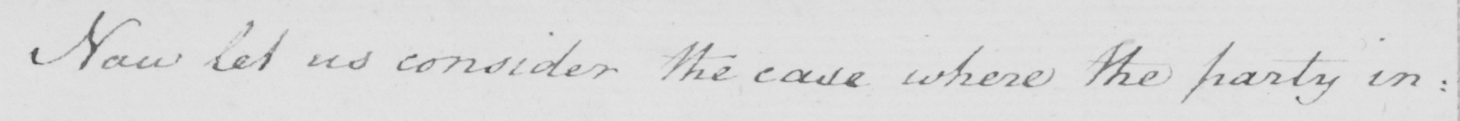Transcribe the text shown in this historical manuscript line. Now let us consider the case where the party in : 